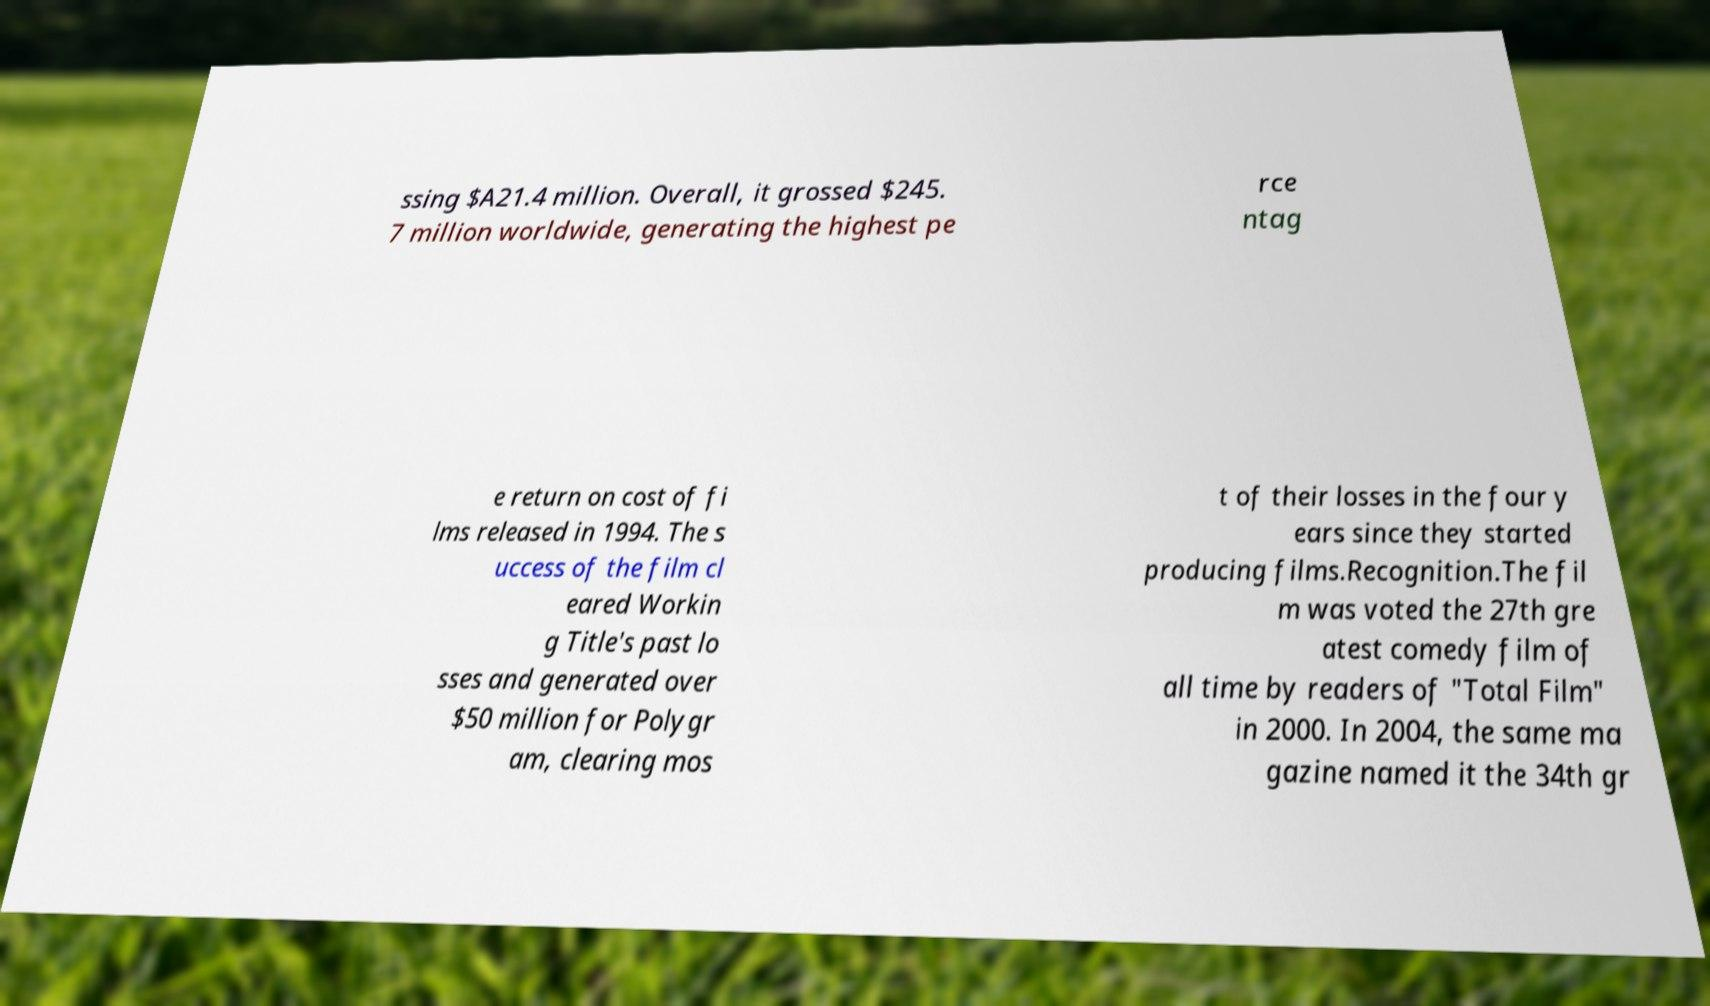Could you assist in decoding the text presented in this image and type it out clearly? ssing $A21.4 million. Overall, it grossed $245. 7 million worldwide, generating the highest pe rce ntag e return on cost of fi lms released in 1994. The s uccess of the film cl eared Workin g Title's past lo sses and generated over $50 million for Polygr am, clearing mos t of their losses in the four y ears since they started producing films.Recognition.The fil m was voted the 27th gre atest comedy film of all time by readers of "Total Film" in 2000. In 2004, the same ma gazine named it the 34th gr 